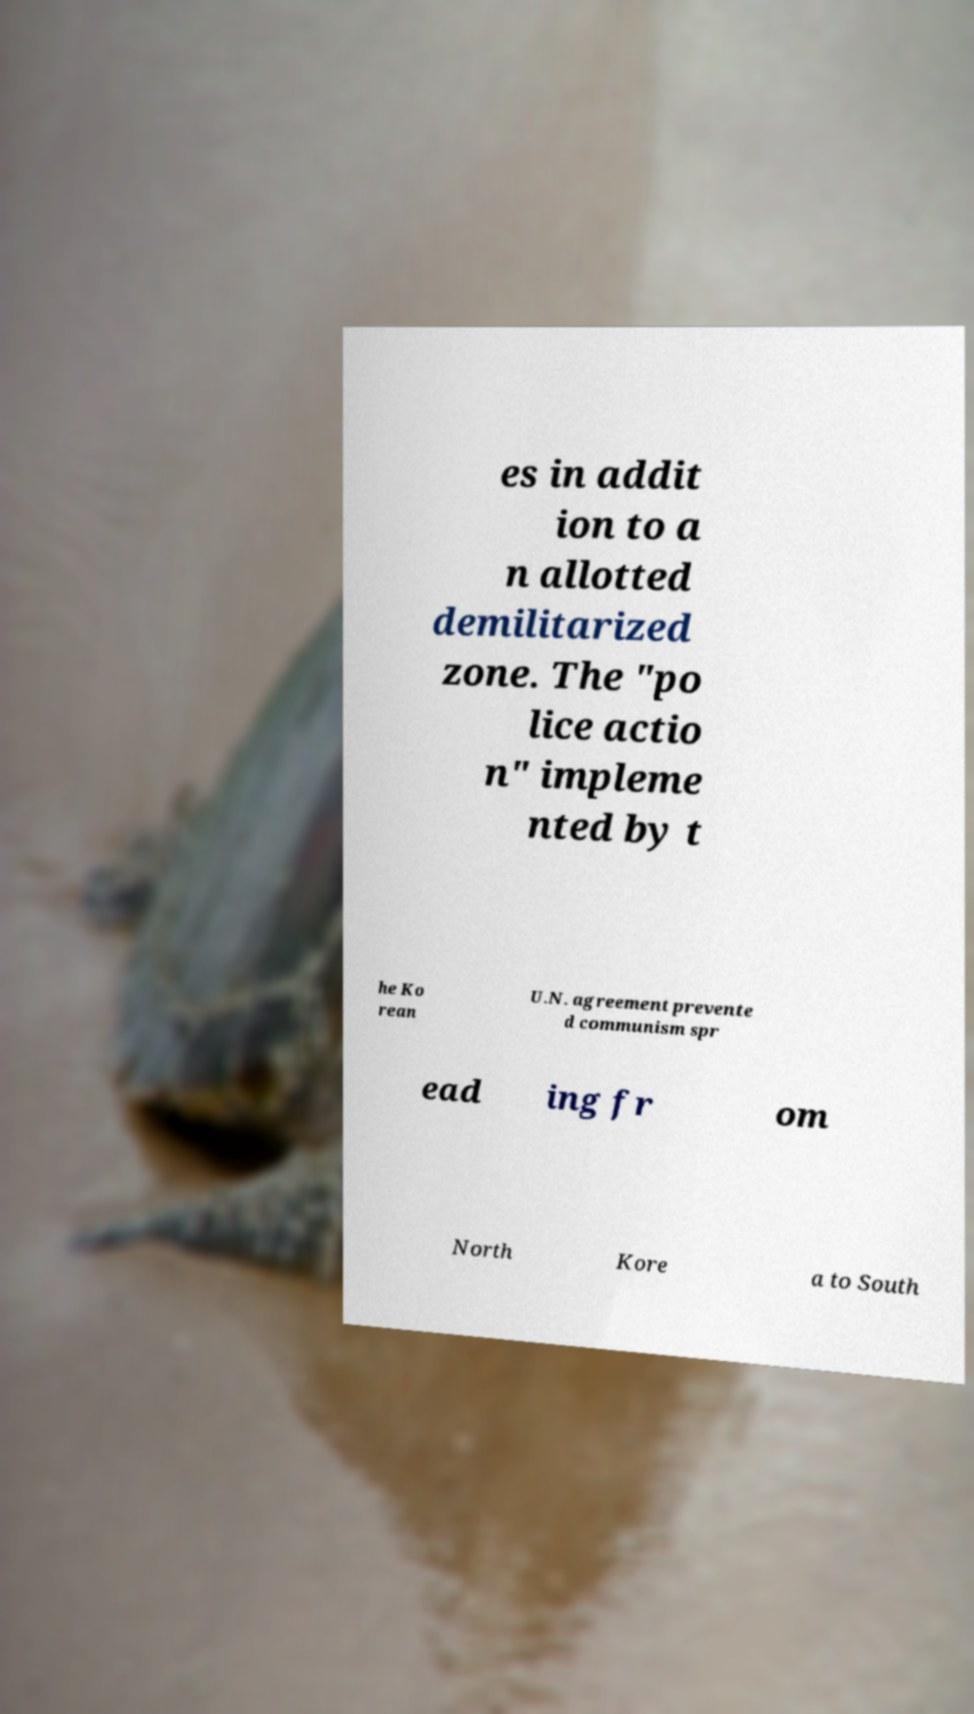Please identify and transcribe the text found in this image. es in addit ion to a n allotted demilitarized zone. The "po lice actio n" impleme nted by t he Ko rean U.N. agreement prevente d communism spr ead ing fr om North Kore a to South 